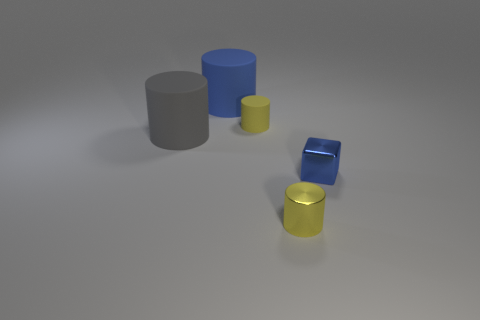Is there a cylinder of the same size as the blue rubber thing?
Your response must be concise. Yes. What is the material of the yellow cylinder behind the big gray rubber object?
Give a very brief answer. Rubber. There is a small thing that is the same material as the large gray object; what is its color?
Ensure brevity in your answer.  Yellow. How many metal objects are either small yellow cylinders or small blue balls?
Give a very brief answer. 1. What shape is the thing that is the same size as the gray matte cylinder?
Offer a terse response. Cylinder. How many objects are blue objects that are in front of the large blue thing or small things behind the tiny blue metal object?
Provide a succinct answer. 2. There is a blue cylinder that is the same size as the gray cylinder; what is its material?
Provide a succinct answer. Rubber. How many other objects are the same material as the blue cube?
Your answer should be compact. 1. Are there the same number of small metallic things that are on the right side of the blue metallic object and yellow metal objects that are left of the yellow metal object?
Give a very brief answer. Yes. What number of blue objects are either big cubes or tiny shiny cubes?
Your response must be concise. 1. 